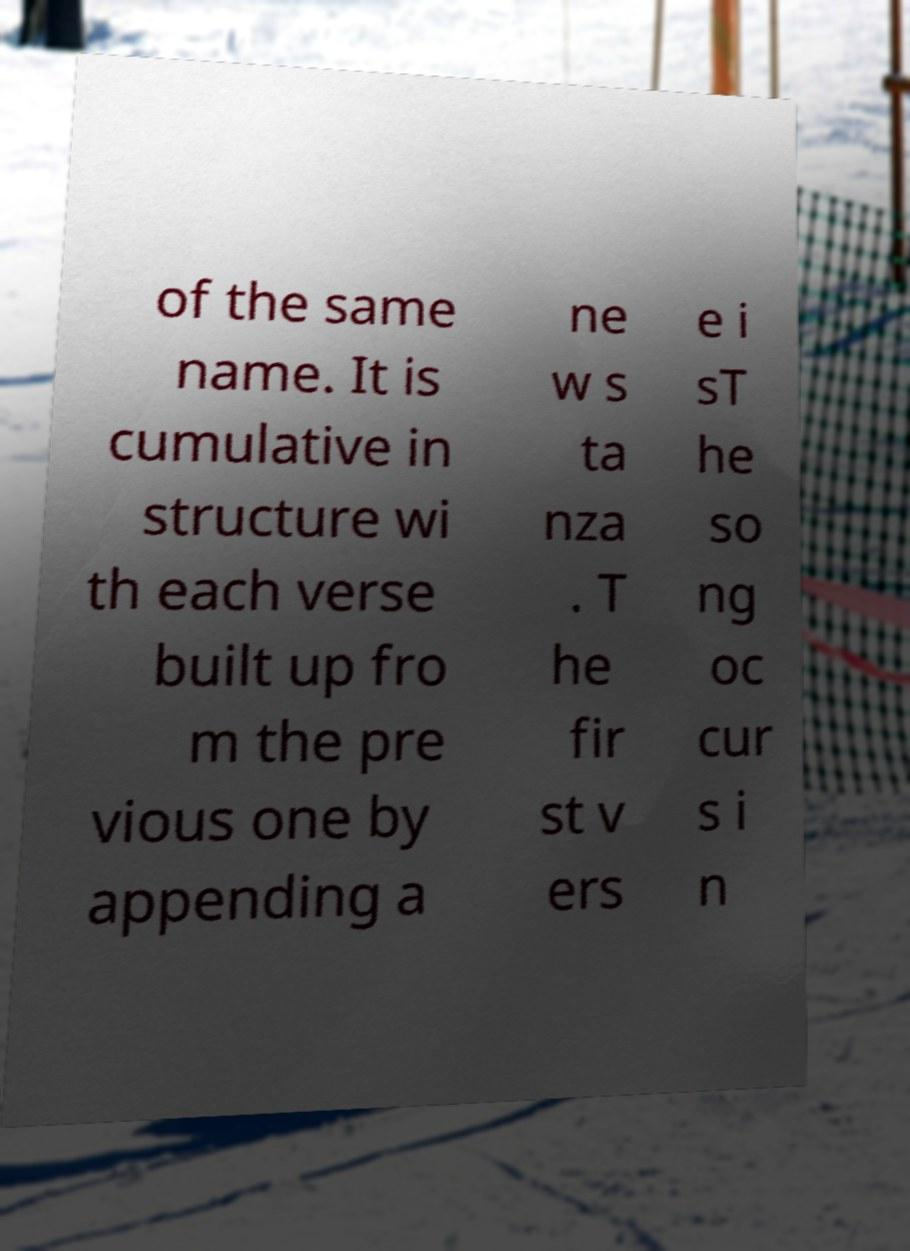Can you read and provide the text displayed in the image?This photo seems to have some interesting text. Can you extract and type it out for me? of the same name. It is cumulative in structure wi th each verse built up fro m the pre vious one by appending a ne w s ta nza . T he fir st v ers e i sT he so ng oc cur s i n 